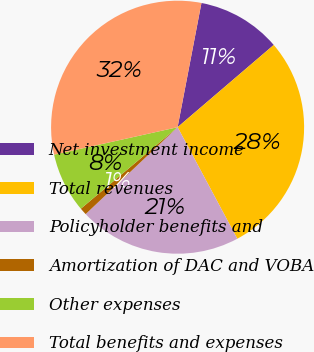<chart> <loc_0><loc_0><loc_500><loc_500><pie_chart><fcel>Net investment income<fcel>Total revenues<fcel>Policyholder benefits and<fcel>Amortization of DAC and VOBA<fcel>Other expenses<fcel>Total benefits and expenses<nl><fcel>10.72%<fcel>28.44%<fcel>20.77%<fcel>0.91%<fcel>7.66%<fcel>31.5%<nl></chart> 